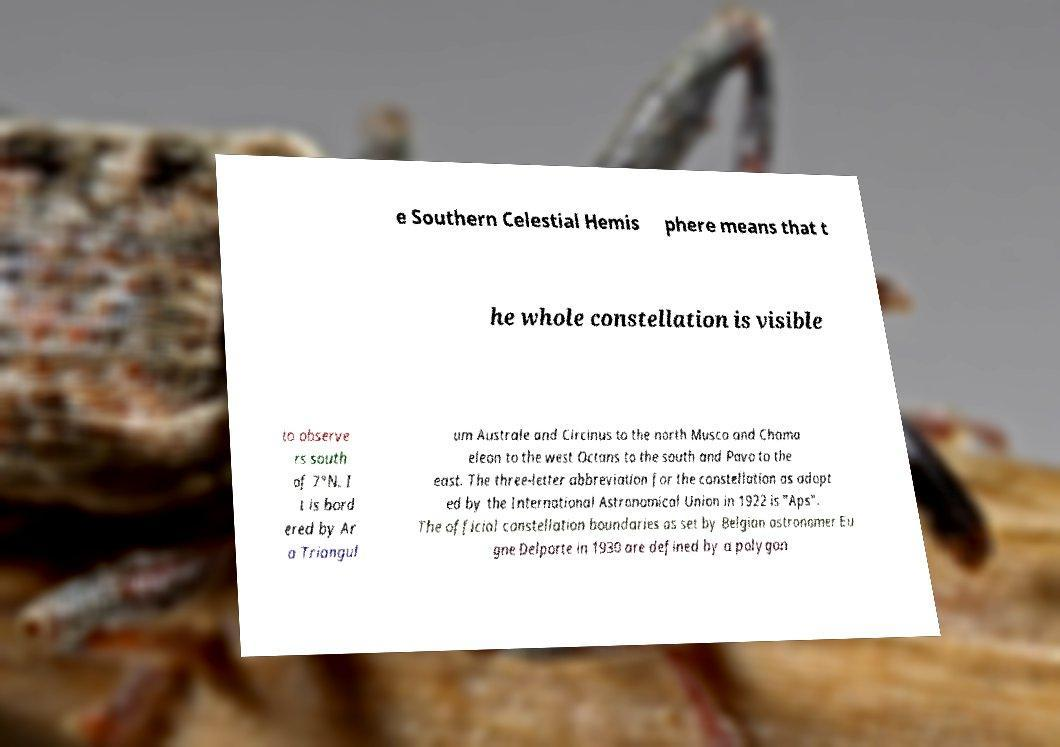There's text embedded in this image that I need extracted. Can you transcribe it verbatim? e Southern Celestial Hemis phere means that t he whole constellation is visible to observe rs south of 7°N. I t is bord ered by Ar a Triangul um Australe and Circinus to the north Musca and Chama eleon to the west Octans to the south and Pavo to the east. The three-letter abbreviation for the constellation as adopt ed by the International Astronomical Union in 1922 is "Aps". The official constellation boundaries as set by Belgian astronomer Eu gne Delporte in 1930 are defined by a polygon 